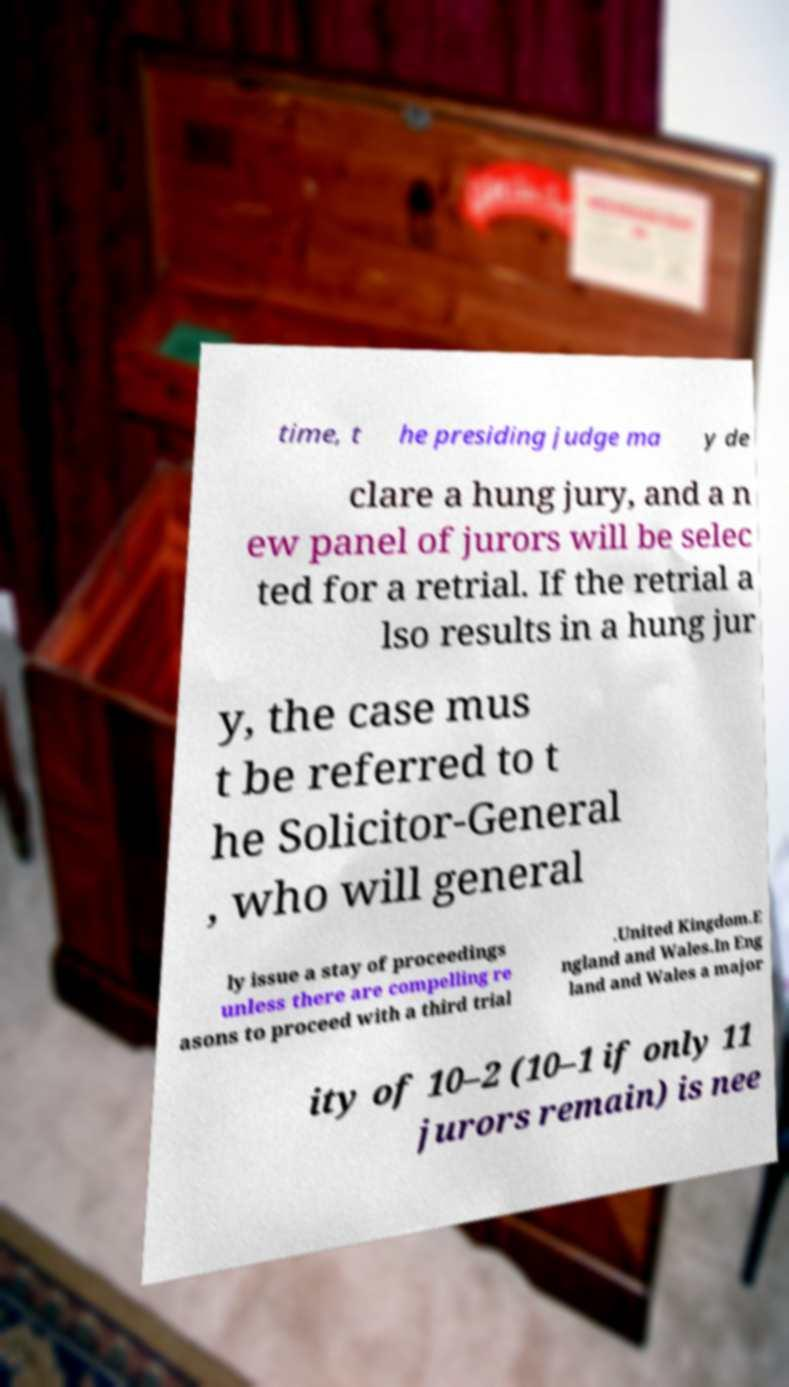Could you assist in decoding the text presented in this image and type it out clearly? time, t he presiding judge ma y de clare a hung jury, and a n ew panel of jurors will be selec ted for a retrial. If the retrial a lso results in a hung jur y, the case mus t be referred to t he Solicitor-General , who will general ly issue a stay of proceedings unless there are compelling re asons to proceed with a third trial .United Kingdom.E ngland and Wales.In Eng land and Wales a major ity of 10–2 (10–1 if only 11 jurors remain) is nee 